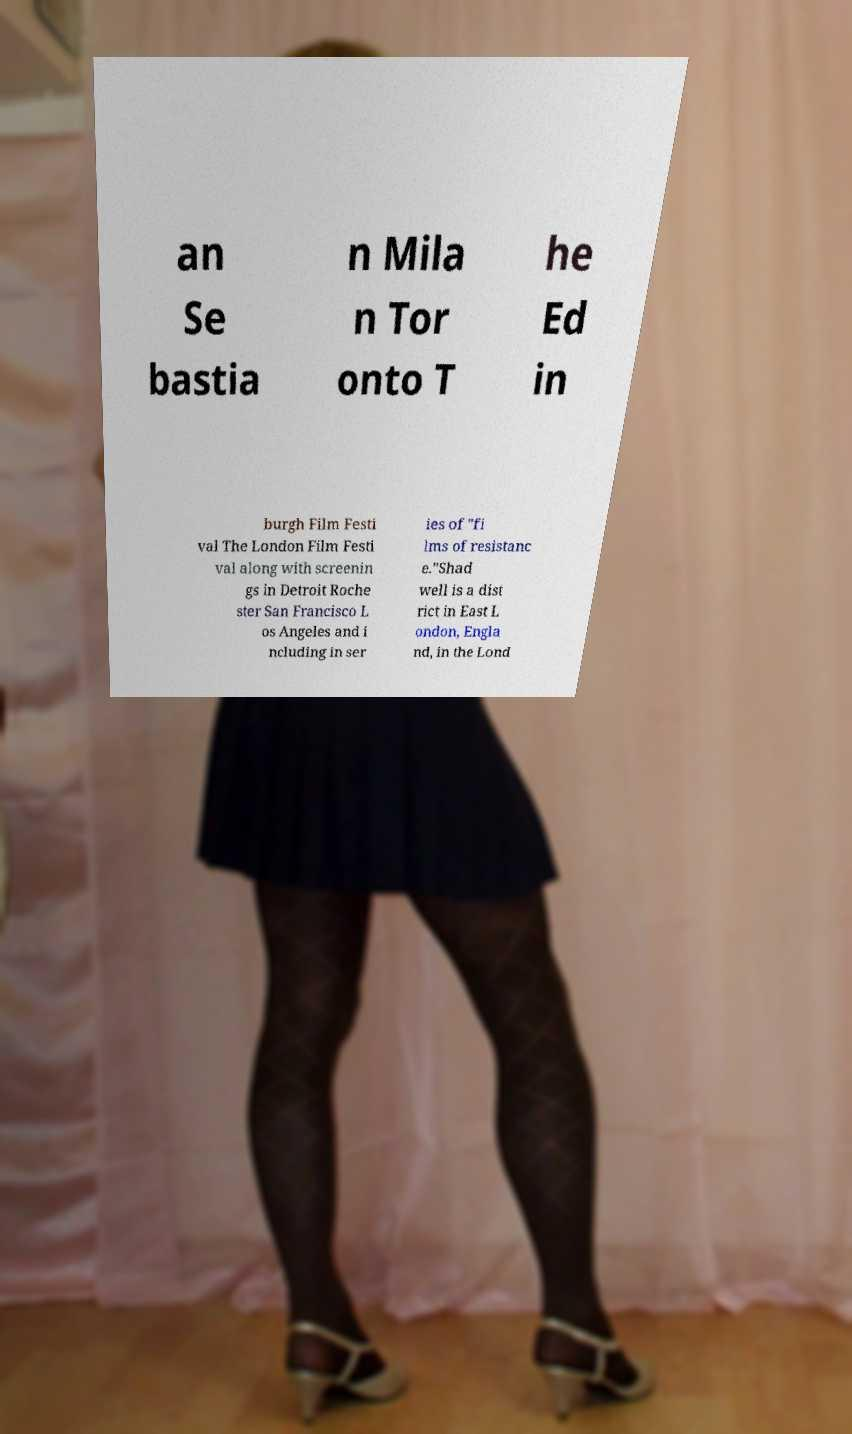Could you extract and type out the text from this image? an Se bastia n Mila n Tor onto T he Ed in burgh Film Festi val The London Film Festi val along with screenin gs in Detroit Roche ster San Francisco L os Angeles and i ncluding in ser ies of "fi lms of resistanc e."Shad well is a dist rict in East L ondon, Engla nd, in the Lond 